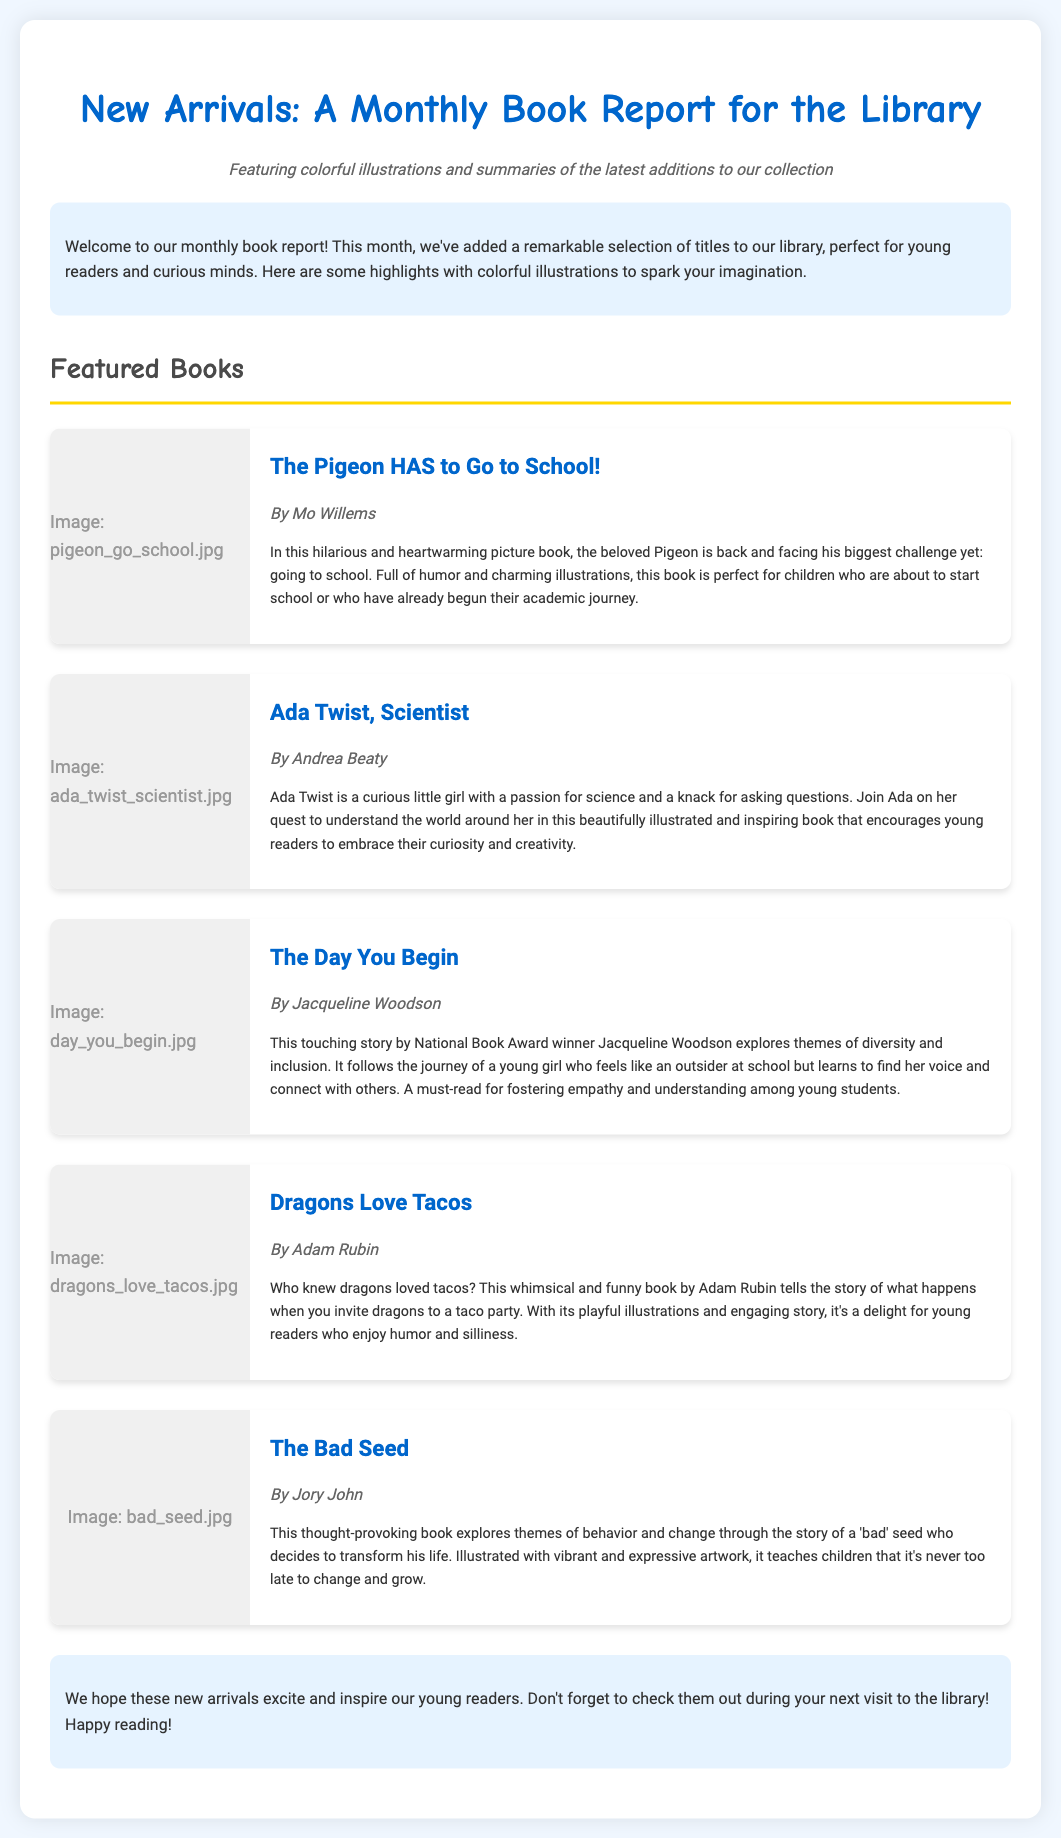What is the title of the report? The title is prominently displayed at the top of the document, introducing the main theme.
Answer: New Arrivals: A Monthly Book Report for the Library Who is the author of "The Pigeon HAS to Go to School!"? This information is found under the title of the respective book section.
Answer: Mo Willems How many books are featured in this report? The number of books can be counted from the sections highlighted in the report.
Answer: Five What theme does "The Day You Begin" explore? The summary clearly states the focus of the book's narrative as part of its description.
Answer: Diversity and inclusion Which book encourages curiosity and creativity? The book's summary describes its purpose and themes related to curiosity and creativity.
Answer: Ada Twist, Scientist What type of illustrations does the report feature? The subtitle mentions the types of visual elements included in the book report.
Answer: Colorful illustrations What is the closing message for readers? The last paragraph summarizes the intent of the report to the audience in a welcoming manner.
Answer: Happy reading! 